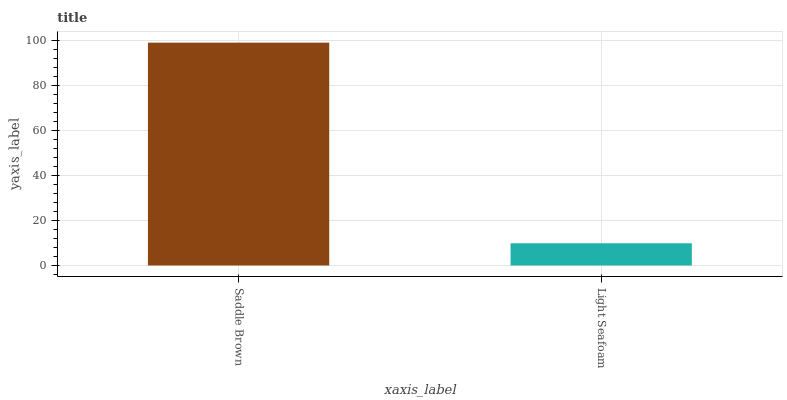Is Light Seafoam the minimum?
Answer yes or no. Yes. Is Saddle Brown the maximum?
Answer yes or no. Yes. Is Light Seafoam the maximum?
Answer yes or no. No. Is Saddle Brown greater than Light Seafoam?
Answer yes or no. Yes. Is Light Seafoam less than Saddle Brown?
Answer yes or no. Yes. Is Light Seafoam greater than Saddle Brown?
Answer yes or no. No. Is Saddle Brown less than Light Seafoam?
Answer yes or no. No. Is Saddle Brown the high median?
Answer yes or no. Yes. Is Light Seafoam the low median?
Answer yes or no. Yes. Is Light Seafoam the high median?
Answer yes or no. No. Is Saddle Brown the low median?
Answer yes or no. No. 